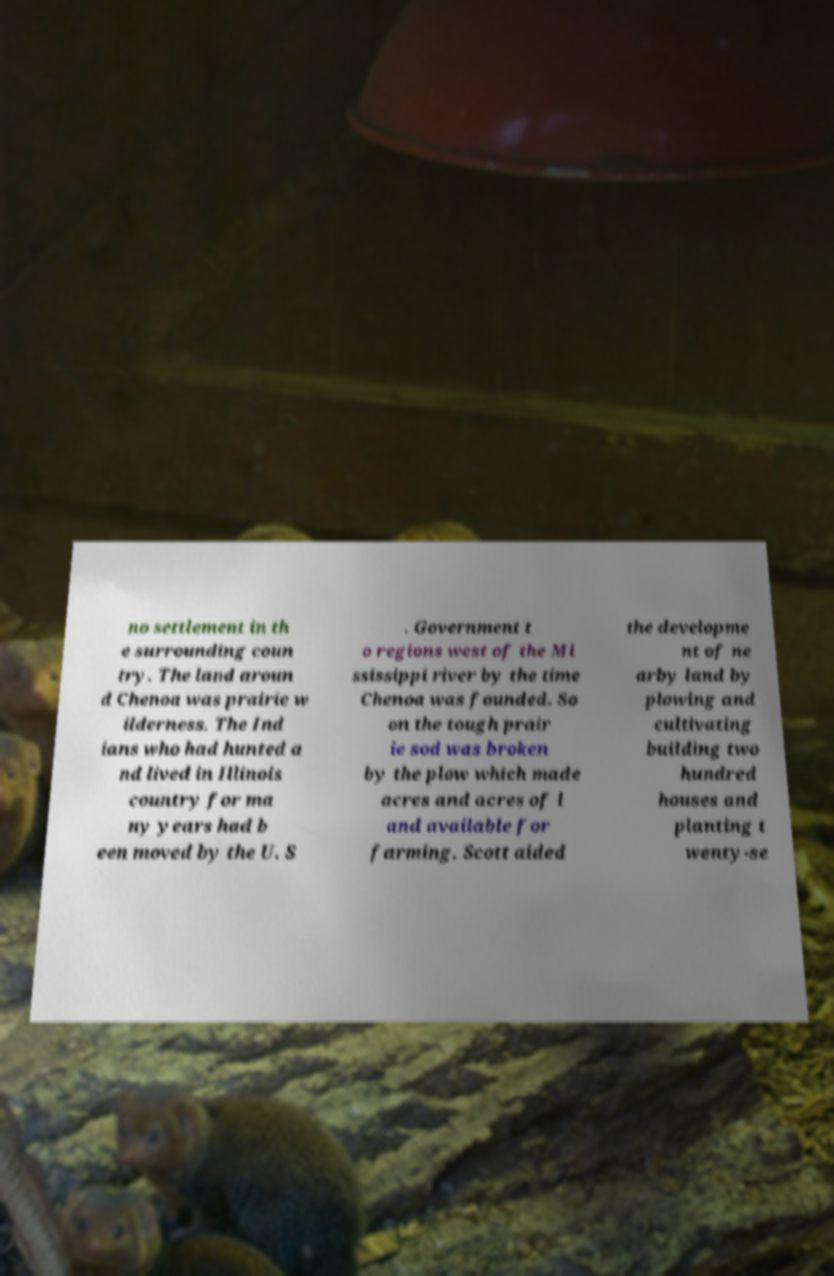I need the written content from this picture converted into text. Can you do that? no settlement in th e surrounding coun try. The land aroun d Chenoa was prairie w ilderness. The Ind ians who had hunted a nd lived in Illinois country for ma ny years had b een moved by the U. S . Government t o regions west of the Mi ssissippi river by the time Chenoa was founded. So on the tough prair ie sod was broken by the plow which made acres and acres of l and available for farming. Scott aided the developme nt of ne arby land by plowing and cultivating building two hundred houses and planting t wenty-se 